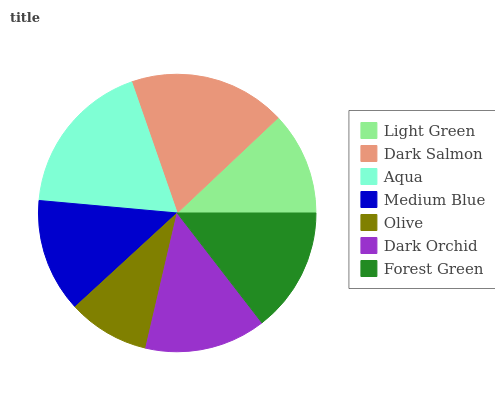Is Olive the minimum?
Answer yes or no. Yes. Is Dark Salmon the maximum?
Answer yes or no. Yes. Is Aqua the minimum?
Answer yes or no. No. Is Aqua the maximum?
Answer yes or no. No. Is Dark Salmon greater than Aqua?
Answer yes or no. Yes. Is Aqua less than Dark Salmon?
Answer yes or no. Yes. Is Aqua greater than Dark Salmon?
Answer yes or no. No. Is Dark Salmon less than Aqua?
Answer yes or no. No. Is Dark Orchid the high median?
Answer yes or no. Yes. Is Dark Orchid the low median?
Answer yes or no. Yes. Is Aqua the high median?
Answer yes or no. No. Is Aqua the low median?
Answer yes or no. No. 